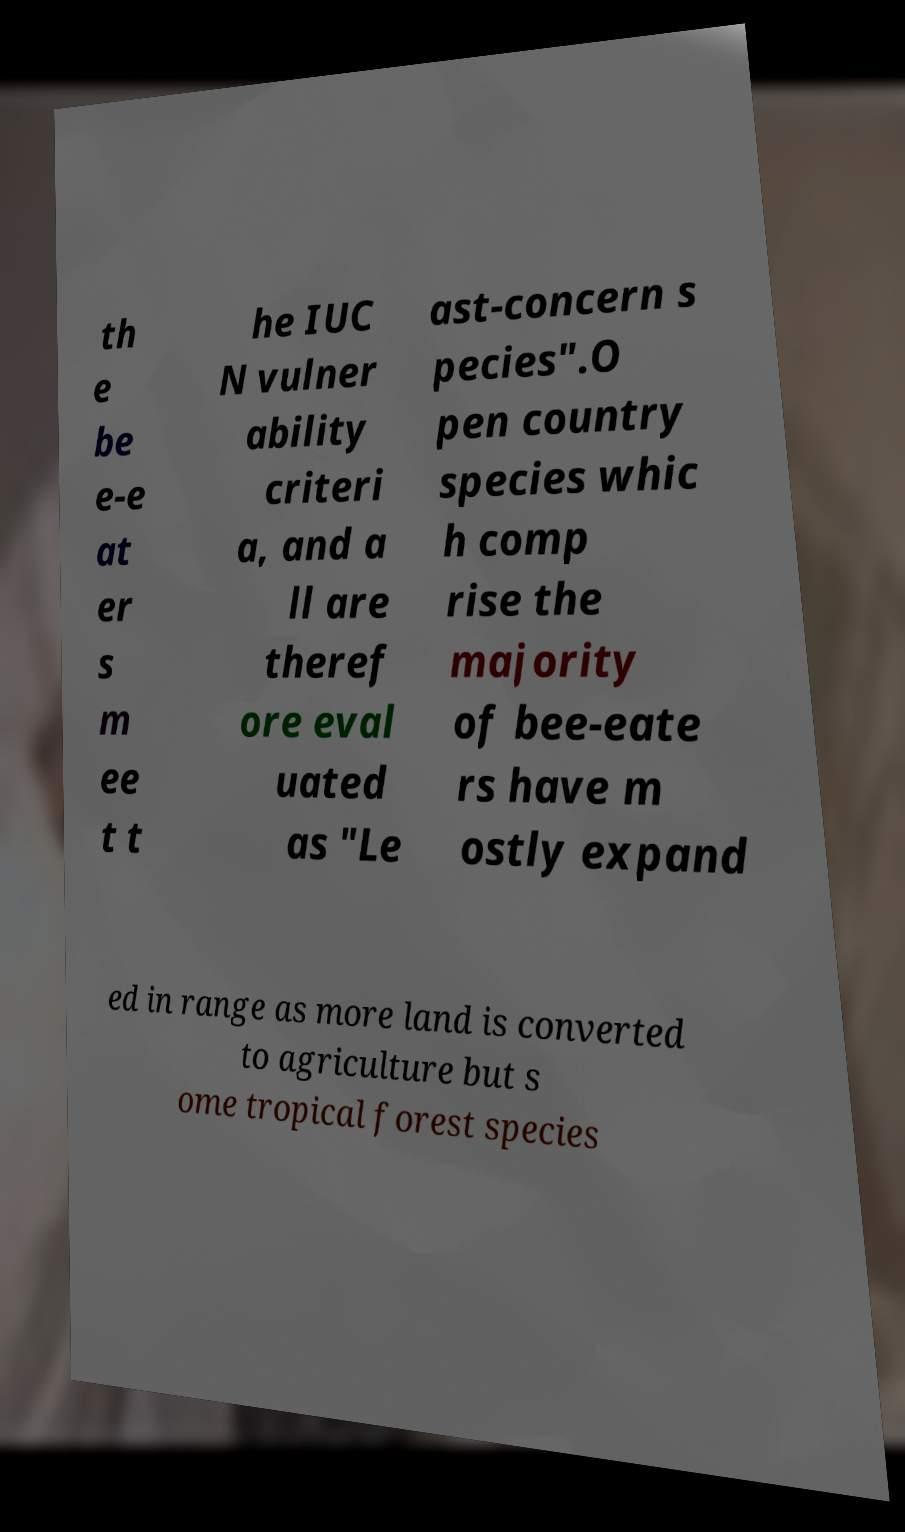Can you accurately transcribe the text from the provided image for me? th e be e-e at er s m ee t t he IUC N vulner ability criteri a, and a ll are theref ore eval uated as "Le ast-concern s pecies".O pen country species whic h comp rise the majority of bee-eate rs have m ostly expand ed in range as more land is converted to agriculture but s ome tropical forest species 